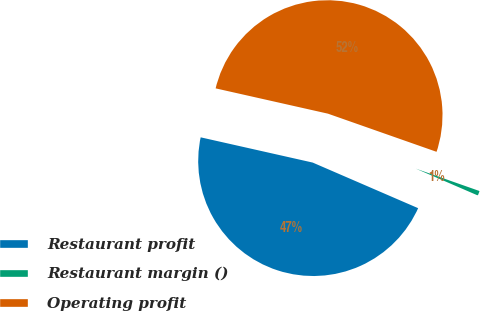Convert chart to OTSL. <chart><loc_0><loc_0><loc_500><loc_500><pie_chart><fcel>Restaurant profit<fcel>Restaurant margin ()<fcel>Operating profit<nl><fcel>47.03%<fcel>1.12%<fcel>51.85%<nl></chart> 